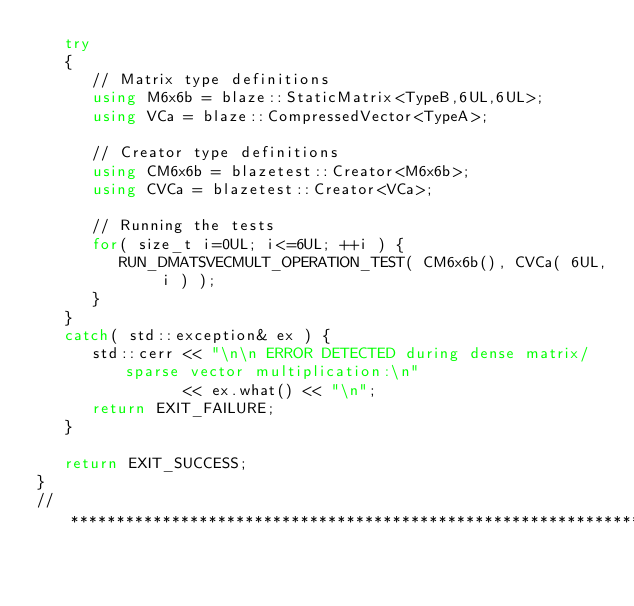Convert code to text. <code><loc_0><loc_0><loc_500><loc_500><_C++_>   try
   {
      // Matrix type definitions
      using M6x6b = blaze::StaticMatrix<TypeB,6UL,6UL>;
      using VCa = blaze::CompressedVector<TypeA>;

      // Creator type definitions
      using CM6x6b = blazetest::Creator<M6x6b>;
      using CVCa = blazetest::Creator<VCa>;

      // Running the tests
      for( size_t i=0UL; i<=6UL; ++i ) {
         RUN_DMATSVECMULT_OPERATION_TEST( CM6x6b(), CVCa( 6UL, i ) );
      }
   }
   catch( std::exception& ex ) {
      std::cerr << "\n\n ERROR DETECTED during dense matrix/sparse vector multiplication:\n"
                << ex.what() << "\n";
      return EXIT_FAILURE;
   }

   return EXIT_SUCCESS;
}
//*************************************************************************************************
</code> 